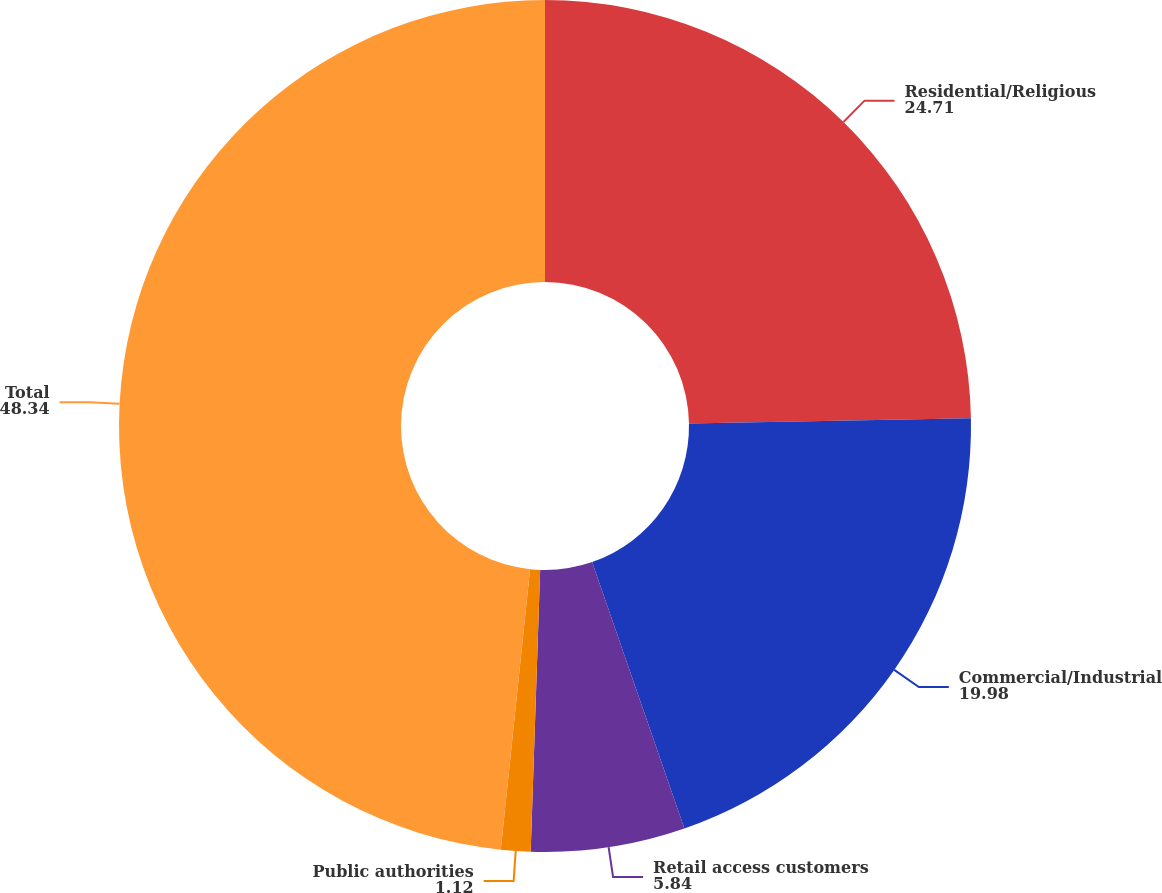<chart> <loc_0><loc_0><loc_500><loc_500><pie_chart><fcel>Residential/Religious<fcel>Commercial/Industrial<fcel>Retail access customers<fcel>Public authorities<fcel>Total<nl><fcel>24.71%<fcel>19.98%<fcel>5.84%<fcel>1.12%<fcel>48.34%<nl></chart> 